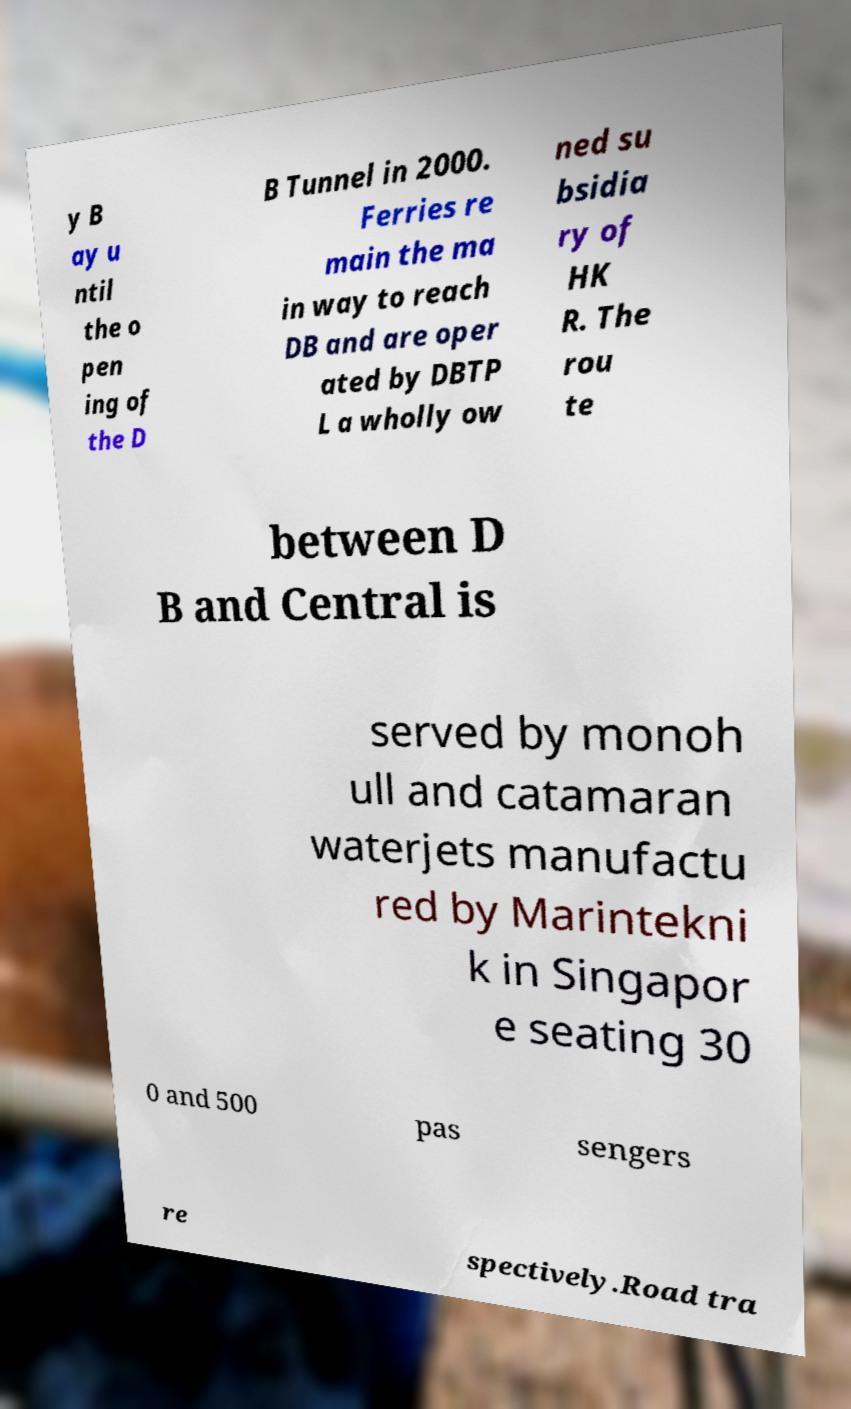Could you assist in decoding the text presented in this image and type it out clearly? y B ay u ntil the o pen ing of the D B Tunnel in 2000. Ferries re main the ma in way to reach DB and are oper ated by DBTP L a wholly ow ned su bsidia ry of HK R. The rou te between D B and Central is served by monoh ull and catamaran waterjets manufactu red by Marintekni k in Singapor e seating 30 0 and 500 pas sengers re spectively.Road tra 